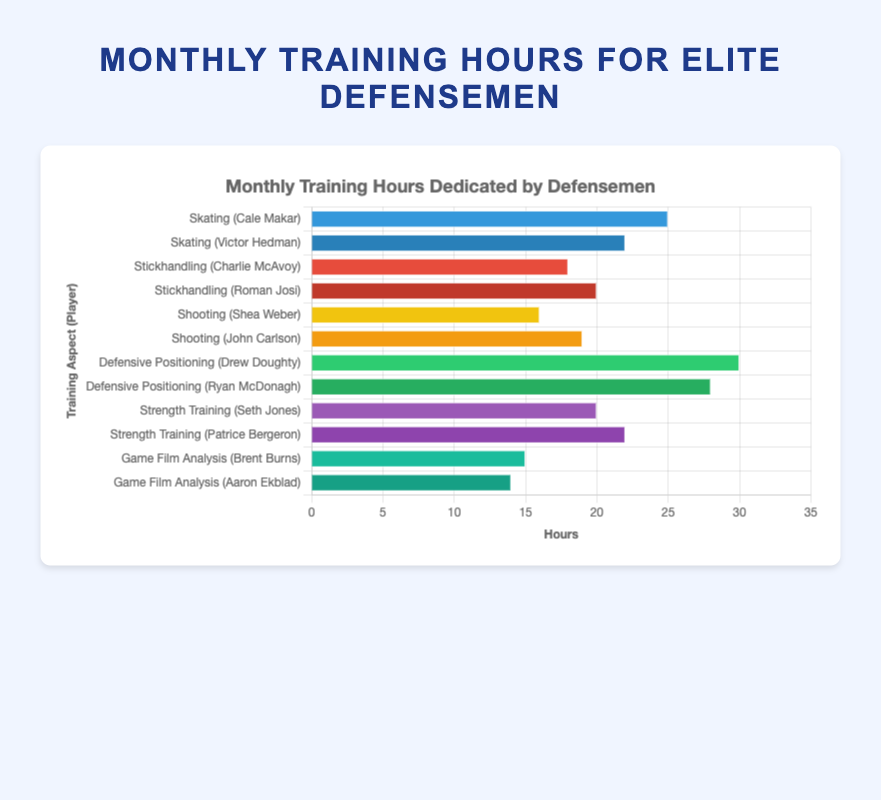Which defenseman spends the most monthly hours on Skating? First, identify the defensemen and their hours for the "Skating" aspect. Cale Makar spends 25 hours, and Victor Hedman spends 22 hours. Since 25 > 22, Cale Makar spends the most monthly hours on Skating.
Answer: Cale Makar How many more hours does Drew Doughty spend on Defensive Positioning compared to Ryan McDonagh? Find the hours spent by both: Drew Doughty spends 30 hours and Ryan McDonagh spends 28 hours. Calculate the difference: 30 - 28 = 2 hours.
Answer: 2 Which aspect of the game has the highest total training hours across all players? Sum the hours for each aspect:
- Skating: 25 + 22 = 47
- Stickhandling: 18 + 20 = 38
- Shooting: 16 + 19 = 35
- Defensive Positioning: 30 + 28 = 58
- Strength Training: 20 + 22 = 42
- Game Film Analysis: 15 + 14 = 29
The highest sum is Defensive Positioning with 58 hours.
Answer: Defensive Positioning Compare the bar lengths for Game Film Analysis: Who has a shorter bar, Brent Burns or Aaron Ekblad? Identify the players for Game Film Analysis. Brent Burns spends 15 hours, and Aaron Ekblad spends 14 hours. Comparing the bars visually, Aaron Ekblad's bar is shorter.
Answer: Aaron Ekblad What is the average monthly training hours spent on Shooting by the two players listed? Sum the hours spent by Shea Weber and John Carlson on Shooting: 16 + 19 = 35. Divide the total by the number of players: 35 / 2 = 17.5 hours.
Answer: 17.5 Which player dedicates the least time to Game Film Analysis? Identify the hours spent by Brent Burns and Aaron Ekblad on Game Film Analysis. Brent Burns spends 15 hours, and Aaron Ekblad spends 14 hours. Aaron Ekblad spends the least time.
Answer: Aaron Ekblad What is the combined monthly training hours for players on Skating and Shooting? Sum the hours for players on Skating (25 + 22) and Shooting (16 + 19):
- Skating: 25 + 22 = 47
- Shooting: 16 + 19 = 35
Combine the two sums: 47 + 35 = 82 hours.
Answer: 82 Compare the hours spent on Strength Training between Seth Jones and Patrice Bergeron. Who spends more time? Identify the hours for Strength Training. Seth Jones spends 20 hours, and Patrice Bergeron spends 22 hours. Comparing these, Patrice Bergeron spends more time.
Answer: Patrice Bergeron 